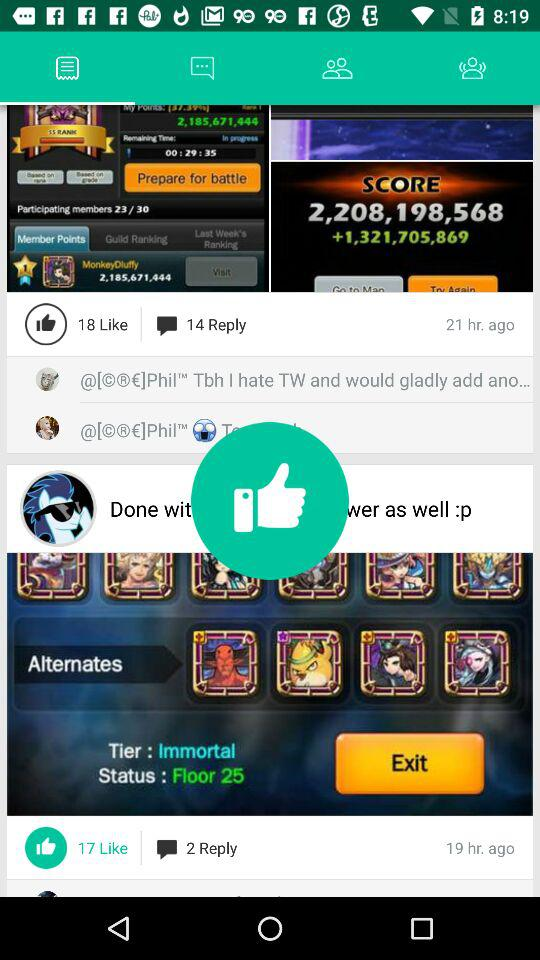When was it last updated?
When the provided information is insufficient, respond with <no answer>. <no answer> 